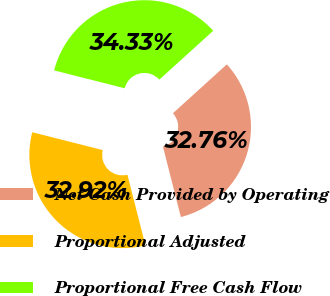Convert chart to OTSL. <chart><loc_0><loc_0><loc_500><loc_500><pie_chart><fcel>Net Cash Provided by Operating<fcel>Proportional Adjusted<fcel>Proportional Free Cash Flow<nl><fcel>32.76%<fcel>32.92%<fcel>34.33%<nl></chart> 